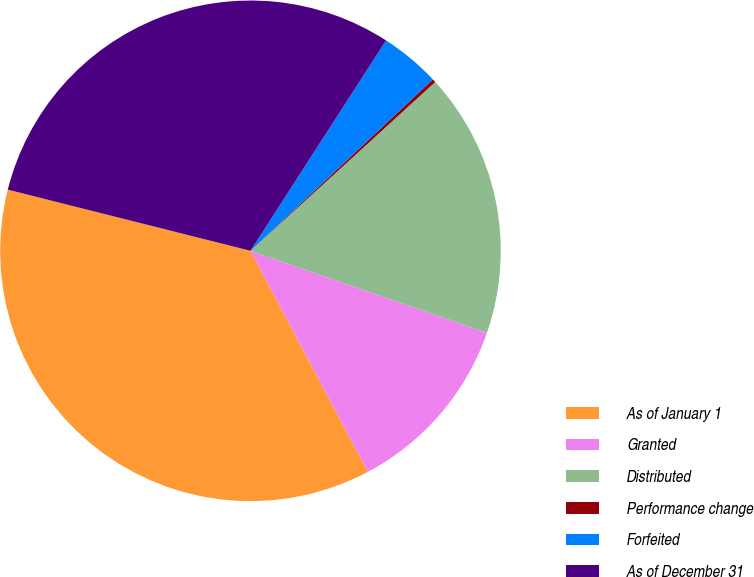Convert chart to OTSL. <chart><loc_0><loc_0><loc_500><loc_500><pie_chart><fcel>As of January 1<fcel>Granted<fcel>Distributed<fcel>Performance change<fcel>Forfeited<fcel>As of December 31<nl><fcel>36.7%<fcel>11.92%<fcel>17.09%<fcel>0.23%<fcel>3.88%<fcel>30.18%<nl></chart> 